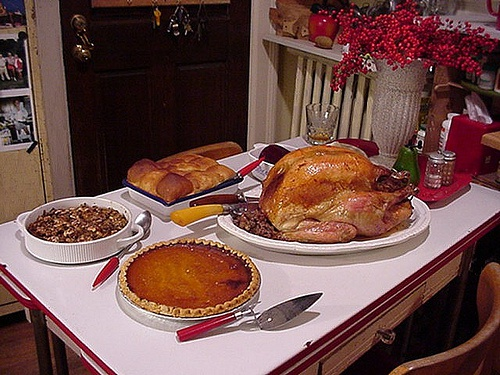Describe the objects in this image and their specific colors. I can see dining table in navy, lightgray, maroon, brown, and black tones, cake in navy, maroon, brown, and tan tones, bowl in navy, lightgray, darkgray, maroon, and gray tones, vase in navy, gray, maroon, and brown tones, and chair in navy, black, maroon, and brown tones in this image. 